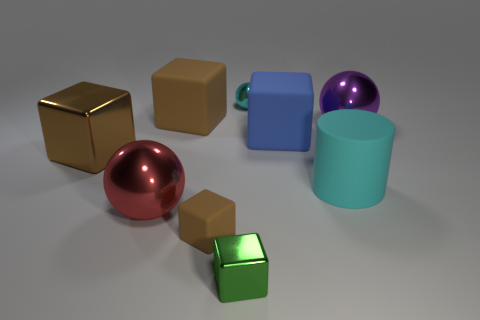Subtract all big brown cubes. How many cubes are left? 3 Subtract all green cylinders. How many brown cubes are left? 3 Subtract all green cubes. How many cubes are left? 4 Subtract all cubes. How many objects are left? 4 Add 7 large spheres. How many large spheres exist? 9 Subtract 0 brown balls. How many objects are left? 9 Subtract 3 balls. How many balls are left? 0 Subtract all purple balls. Subtract all yellow cylinders. How many balls are left? 2 Subtract all large blue things. Subtract all large purple shiny balls. How many objects are left? 7 Add 3 blue things. How many blue things are left? 4 